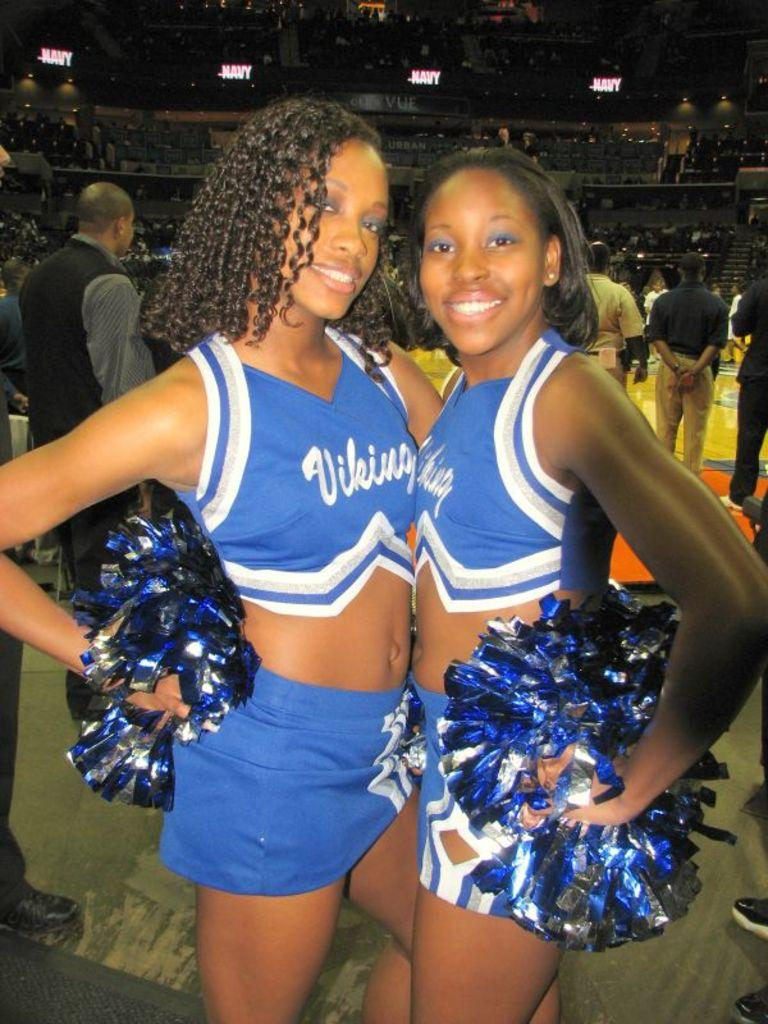<image>
Share a concise interpretation of the image provided. Vikings are the team that the girls are cheering for. 